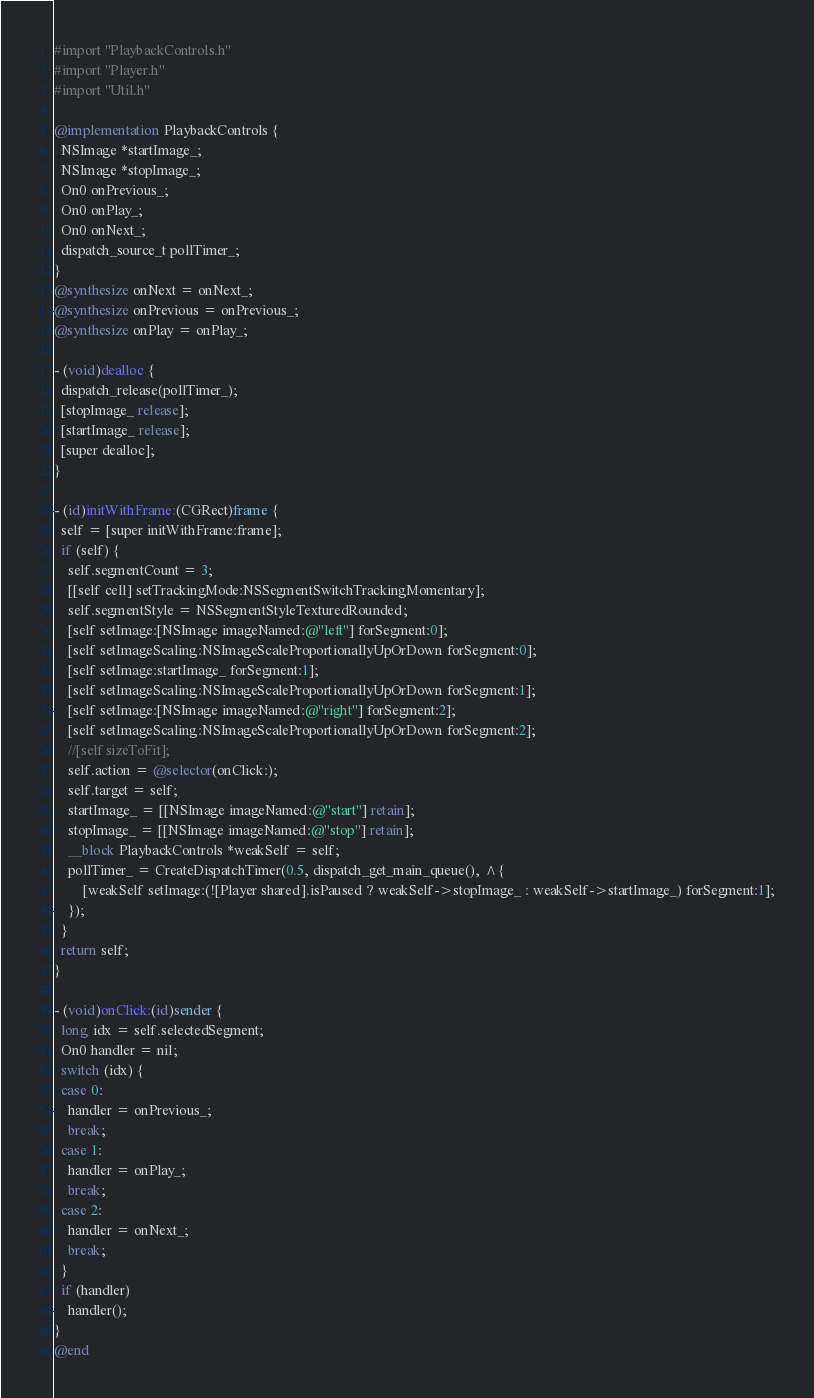Convert code to text. <code><loc_0><loc_0><loc_500><loc_500><_ObjectiveC_>#import "PlaybackControls.h"
#import "Player.h"
#import "Util.h"

@implementation PlaybackControls {
  NSImage *startImage_;
  NSImage *stopImage_;
  On0 onPrevious_;
  On0 onPlay_;
  On0 onNext_;
  dispatch_source_t pollTimer_;
}
@synthesize onNext = onNext_;
@synthesize onPrevious = onPrevious_;
@synthesize onPlay = onPlay_;

- (void)dealloc {
  dispatch_release(pollTimer_);
  [stopImage_ release];
  [startImage_ release];
  [super dealloc];
}

- (id)initWithFrame:(CGRect)frame {
  self = [super initWithFrame:frame];
  if (self) {
    self.segmentCount = 3;
    [[self cell] setTrackingMode:NSSegmentSwitchTrackingMomentary];
    self.segmentStyle = NSSegmentStyleTexturedRounded;
    [self setImage:[NSImage imageNamed:@"left"] forSegment:0];
    [self setImageScaling:NSImageScaleProportionallyUpOrDown forSegment:0];
    [self setImage:startImage_ forSegment:1];
    [self setImageScaling:NSImageScaleProportionallyUpOrDown forSegment:1];
    [self setImage:[NSImage imageNamed:@"right"] forSegment:2];
    [self setImageScaling:NSImageScaleProportionallyUpOrDown forSegment:2];
    //[self sizeToFit];
    self.action = @selector(onClick:);
    self.target = self;
    startImage_ = [[NSImage imageNamed:@"start"] retain];
    stopImage_ = [[NSImage imageNamed:@"stop"] retain];
    __block PlaybackControls *weakSelf = self;
    pollTimer_ = CreateDispatchTimer(0.5, dispatch_get_main_queue(), ^{
        [weakSelf setImage:(![Player shared].isPaused ? weakSelf->stopImage_ : weakSelf->startImage_) forSegment:1];
    });
  }
  return self;
}

- (void)onClick:(id)sender {
  long idx = self.selectedSegment;
  On0 handler = nil;
  switch (idx) {
  case 0:
    handler = onPrevious_;
    break;
  case 1:
    handler = onPlay_;
    break;
  case 2:
    handler = onNext_;
    break;
  }
  if (handler)
    handler();
}
@end

</code> 